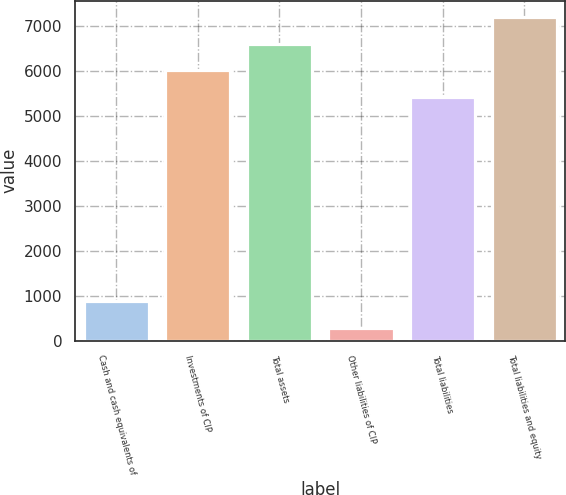Convert chart. <chart><loc_0><loc_0><loc_500><loc_500><bar_chart><fcel>Cash and cash equivalents of<fcel>Investments of CIP<fcel>Total assets<fcel>Other liabilities of CIP<fcel>Total liabilities<fcel>Total liabilities and equity<nl><fcel>875.75<fcel>6025.35<fcel>6620.2<fcel>280.9<fcel>5430.5<fcel>7215.05<nl></chart> 